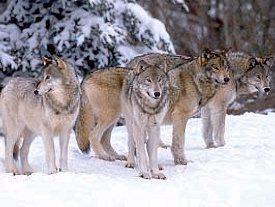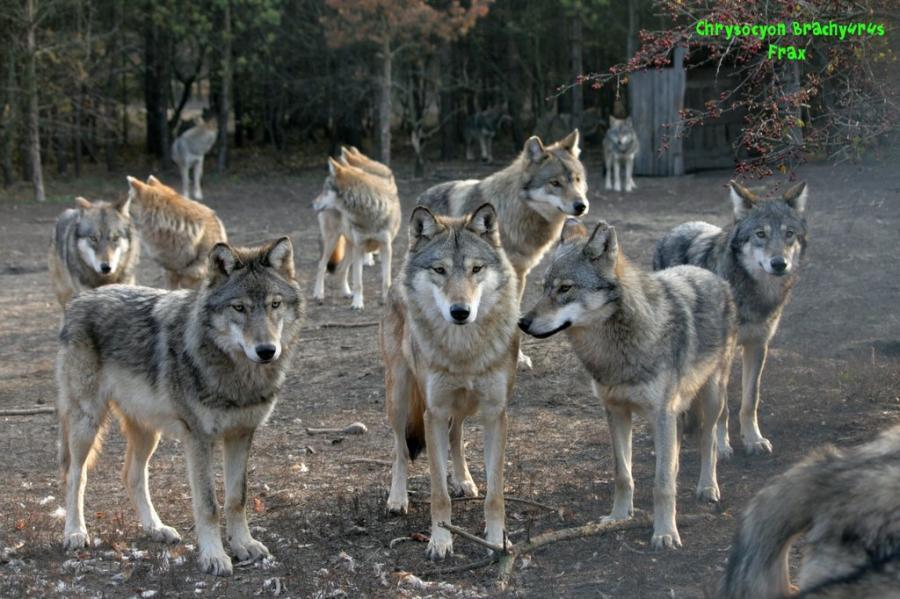The first image is the image on the left, the second image is the image on the right. Considering the images on both sides, is "The wolves are in the snow in only one of the images." valid? Answer yes or no. Yes. The first image is the image on the left, the second image is the image on the right. Given the left and right images, does the statement "In only one of the two images do all the animals appear to be focused on the same thing." hold true? Answer yes or no. No. 